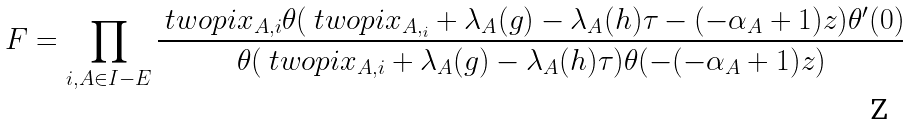<formula> <loc_0><loc_0><loc_500><loc_500>F = \prod _ { i , A \in I - E } \frac { \ t w o p i { x _ { A , i } } \theta ( \ t w o p i { x _ { A , _ { i } } } + \lambda _ { A } ( g ) - \lambda _ { A } ( h ) \tau - ( - \alpha _ { A } + 1 ) z ) \theta ^ { \prime } ( 0 ) } { \theta ( \ t w o p i { x _ { A , i } } + \lambda _ { A } ( g ) - \lambda _ { A } ( h ) \tau ) \theta ( - ( - \alpha _ { A } + 1 ) z ) }</formula> 